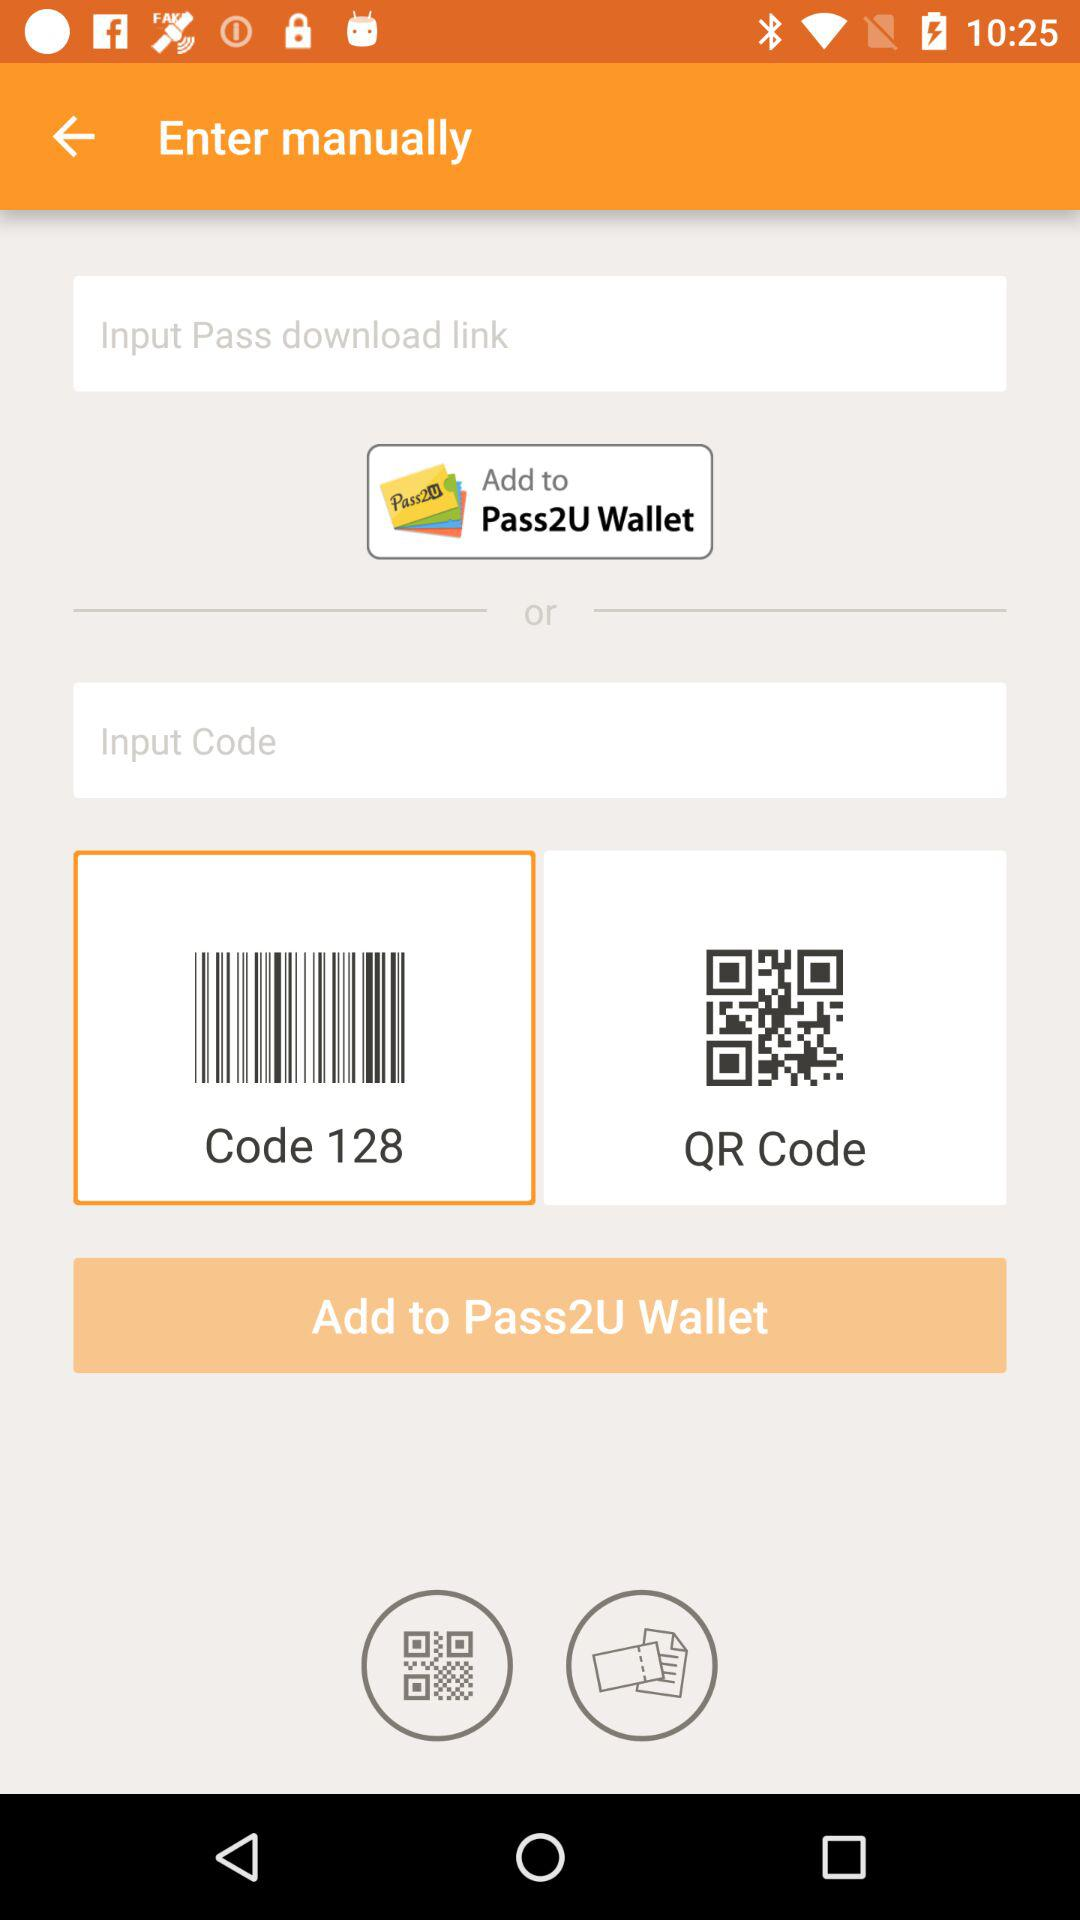What is code?
When the provided information is insufficient, respond with <no answer>. <no answer> 